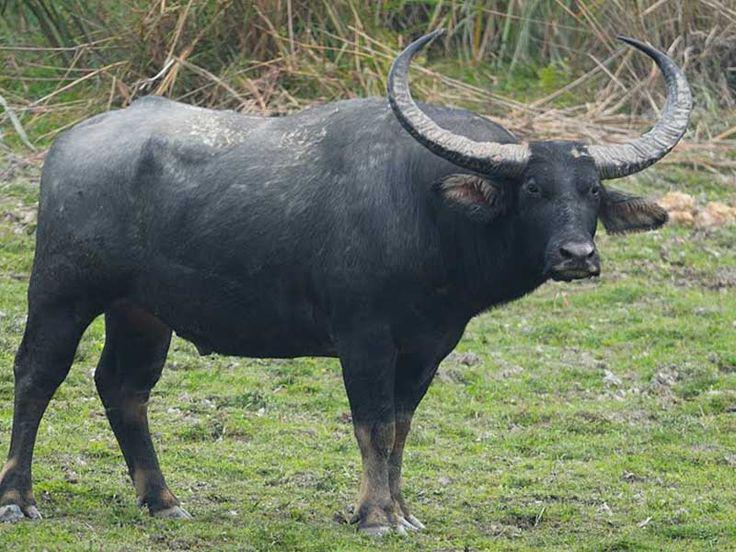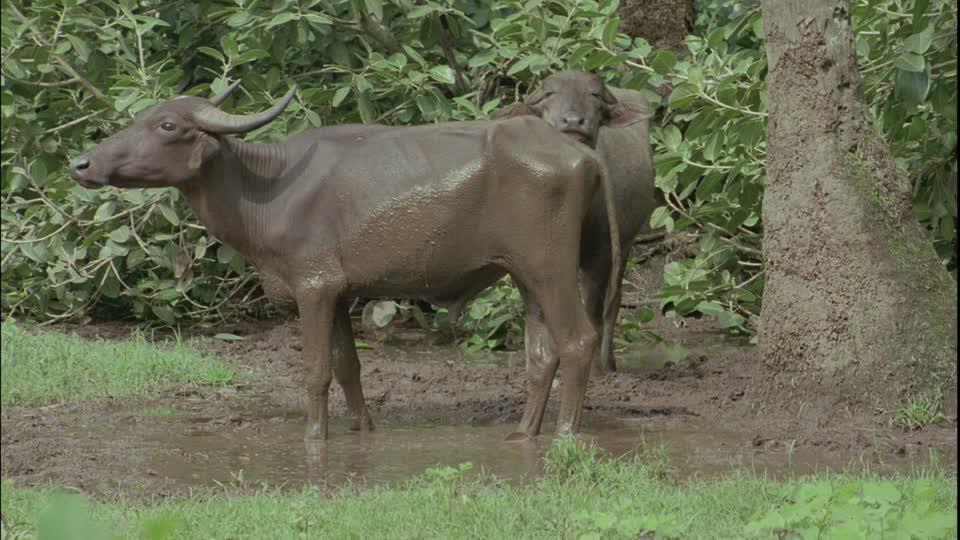The first image is the image on the left, the second image is the image on the right. Assess this claim about the two images: "IN at least one image there is a bull the is the same color as the dirt water it is in.". Correct or not? Answer yes or no. Yes. The first image is the image on the left, the second image is the image on the right. Evaluate the accuracy of this statement regarding the images: "A buffalo is completely covered in mud.". Is it true? Answer yes or no. Yes. 